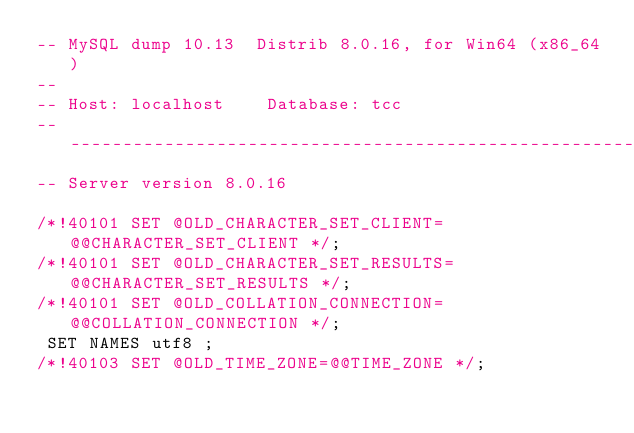<code> <loc_0><loc_0><loc_500><loc_500><_SQL_>-- MySQL dump 10.13  Distrib 8.0.16, for Win64 (x86_64)
--
-- Host: localhost    Database: tcc
-- ------------------------------------------------------
-- Server version	8.0.16

/*!40101 SET @OLD_CHARACTER_SET_CLIENT=@@CHARACTER_SET_CLIENT */;
/*!40101 SET @OLD_CHARACTER_SET_RESULTS=@@CHARACTER_SET_RESULTS */;
/*!40101 SET @OLD_COLLATION_CONNECTION=@@COLLATION_CONNECTION */;
 SET NAMES utf8 ;
/*!40103 SET @OLD_TIME_ZONE=@@TIME_ZONE */;</code> 